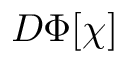<formula> <loc_0><loc_0><loc_500><loc_500>D \Phi [ \chi ]</formula> 